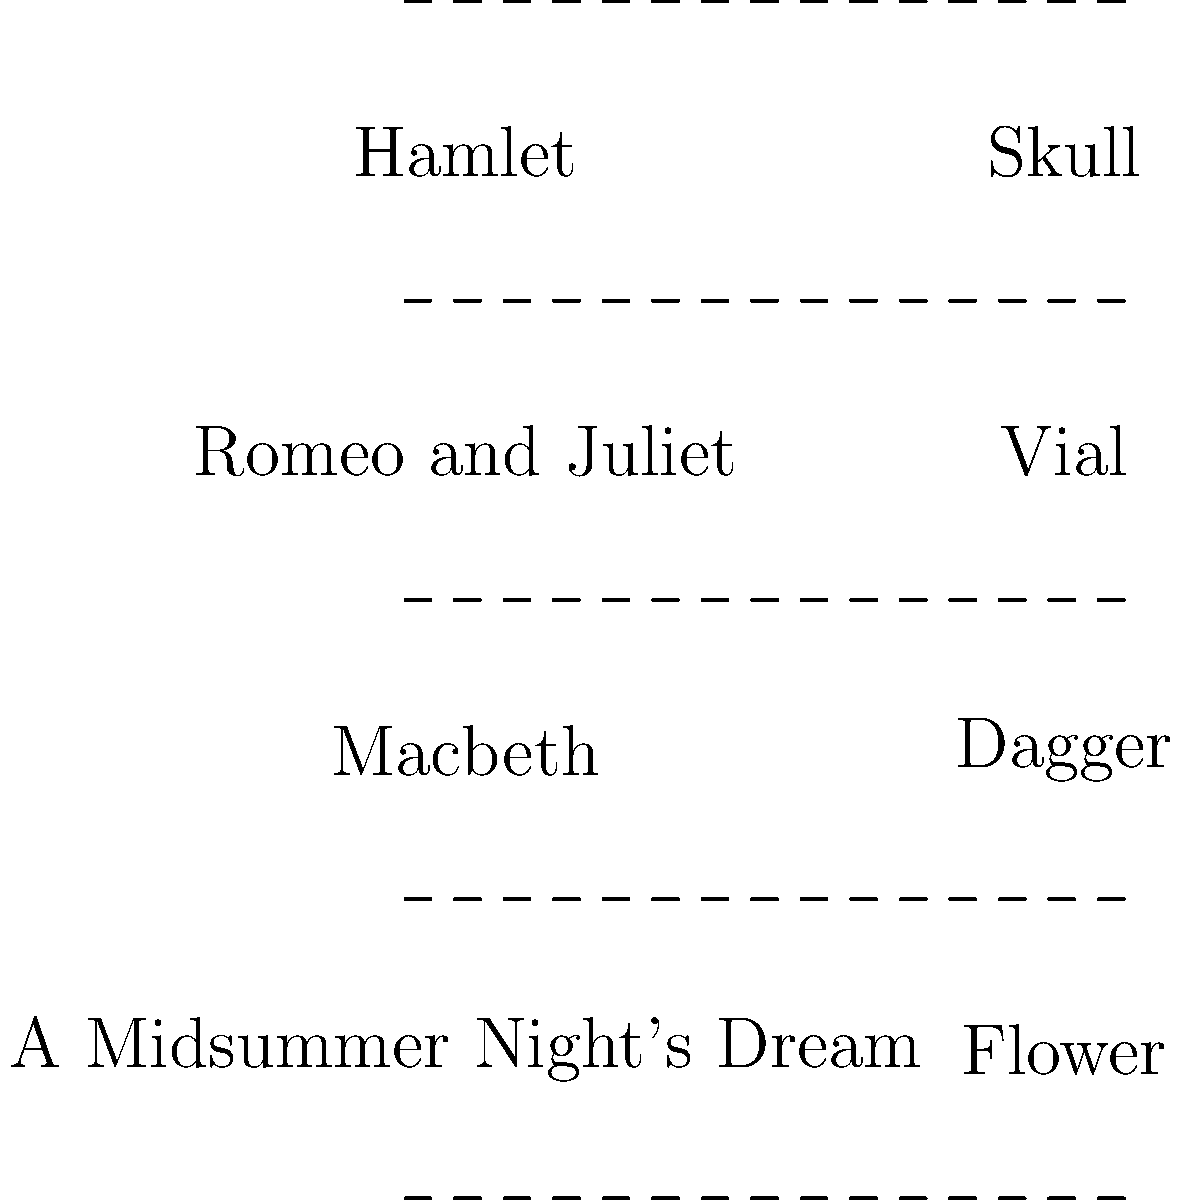Match the stage props on the right to their corresponding plays on the left. Which prop is associated with the play "Macbeth"? To answer this question, let's consider each play and its iconic prop:

1. Hamlet: The skull is a famous prop from the "Alas, poor Yorick" scene.
2. Romeo and Juliet: The vial represents the poison that the lovers use.
3. Macbeth: The dagger is central to Macbeth's famous "Is this a dagger which I see before me" soliloquy.
4. A Midsummer Night's Dream: The flower is associated with the love potion used in this comedy.

For "Macbeth," the prop most closely associated with the play is the dagger. It's a crucial symbol in one of the most famous scenes, where Macbeth hallucinates a floating dagger before he commits murder.
Answer: Dagger 